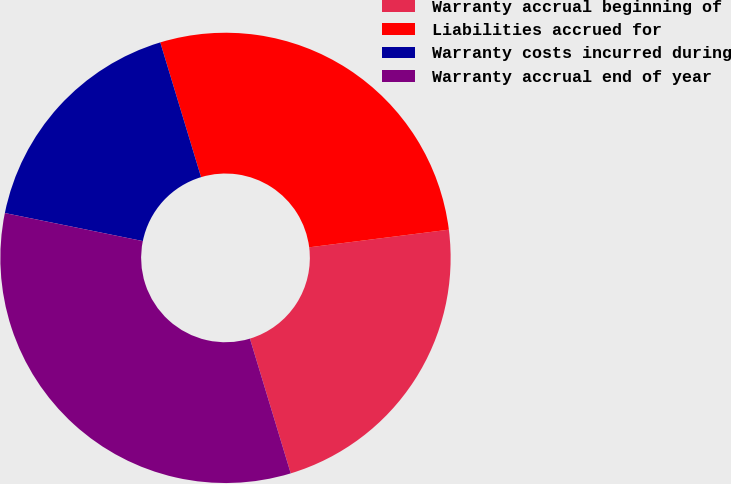Convert chart to OTSL. <chart><loc_0><loc_0><loc_500><loc_500><pie_chart><fcel>Warranty accrual beginning of<fcel>Liabilities accrued for<fcel>Warranty costs incurred during<fcel>Warranty accrual end of year<nl><fcel>22.32%<fcel>27.68%<fcel>17.13%<fcel>32.87%<nl></chart> 